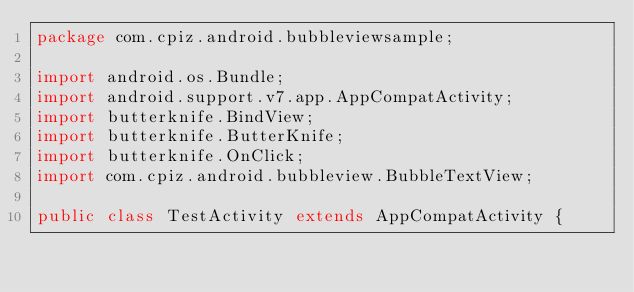Convert code to text. <code><loc_0><loc_0><loc_500><loc_500><_Java_>package com.cpiz.android.bubbleviewsample;

import android.os.Bundle;
import android.support.v7.app.AppCompatActivity;
import butterknife.BindView;
import butterknife.ButterKnife;
import butterknife.OnClick;
import com.cpiz.android.bubbleview.BubbleTextView;

public class TestActivity extends AppCompatActivity {
</code> 